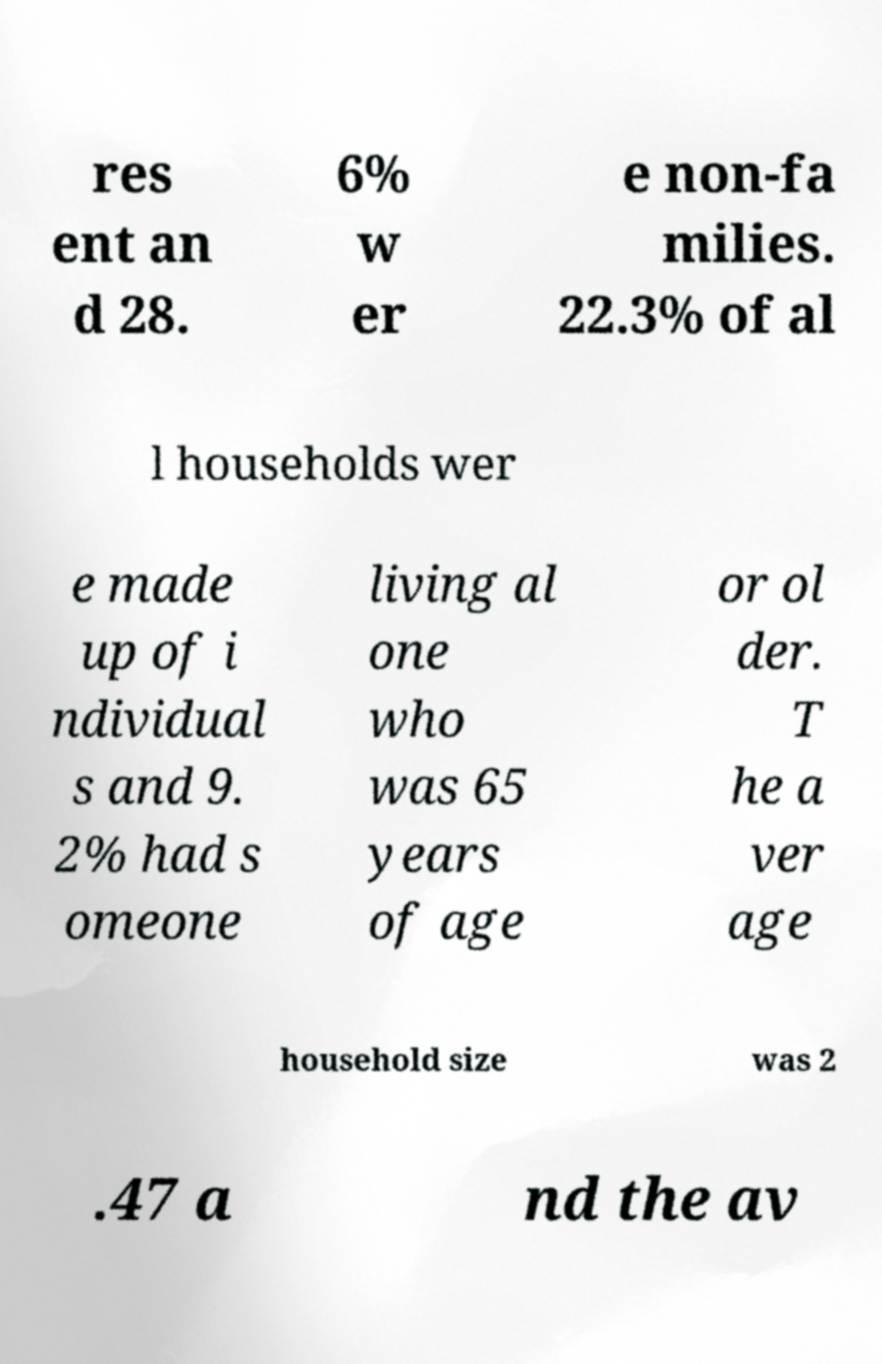Can you read and provide the text displayed in the image?This photo seems to have some interesting text. Can you extract and type it out for me? res ent an d 28. 6% w er e non-fa milies. 22.3% of al l households wer e made up of i ndividual s and 9. 2% had s omeone living al one who was 65 years of age or ol der. T he a ver age household size was 2 .47 a nd the av 